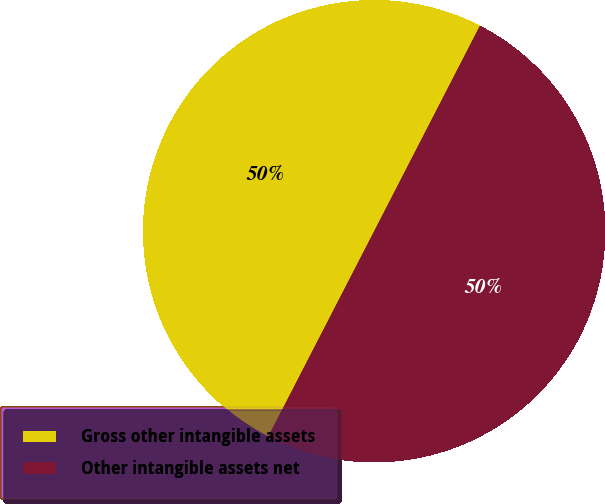Convert chart to OTSL. <chart><loc_0><loc_0><loc_500><loc_500><pie_chart><fcel>Gross other intangible assets<fcel>Other intangible assets net<nl><fcel>49.99%<fcel>50.01%<nl></chart> 